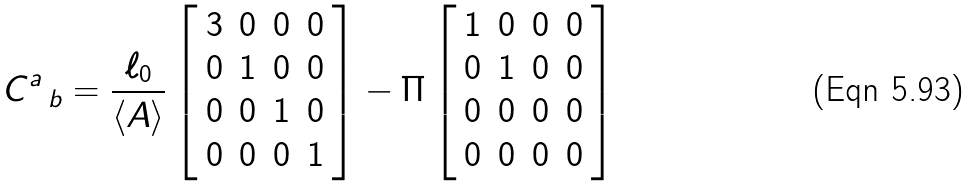Convert formula to latex. <formula><loc_0><loc_0><loc_500><loc_500>C ^ { a } \, _ { b } = \frac { \ell _ { 0 } } { \langle A \rangle } \left [ \begin{array} { c c c c } 3 & 0 & 0 & 0 \\ 0 & 1 & 0 & 0 \\ 0 & 0 & 1 & 0 \\ 0 & 0 & 0 & 1 \end{array} \right ] - \Pi \left [ \begin{array} { c c c c } 1 & 0 & 0 & 0 \\ 0 & 1 & 0 & 0 \\ 0 & 0 & 0 & 0 \\ 0 & 0 & 0 & 0 \end{array} \right ]</formula> 